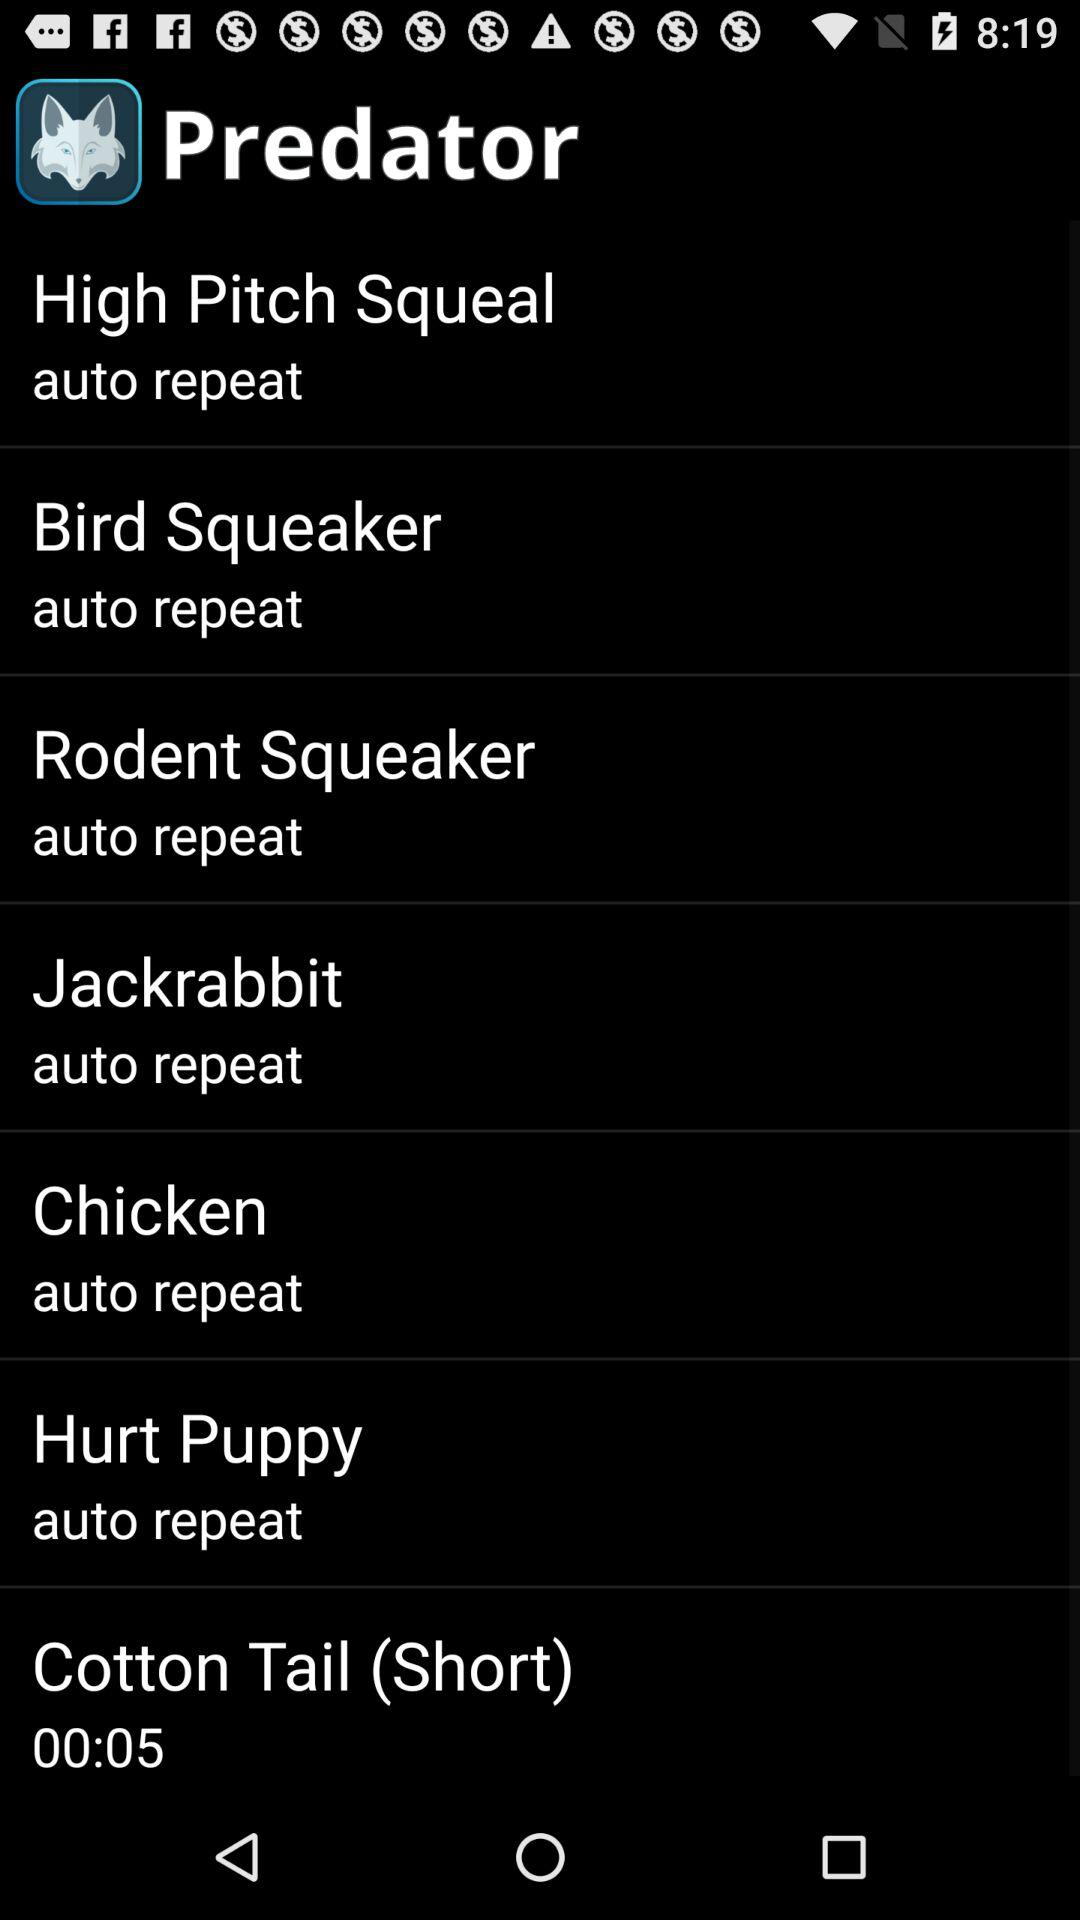How many sound effects have an auto repeat option?
Answer the question using a single word or phrase. 6 